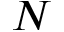<formula> <loc_0><loc_0><loc_500><loc_500>N</formula> 